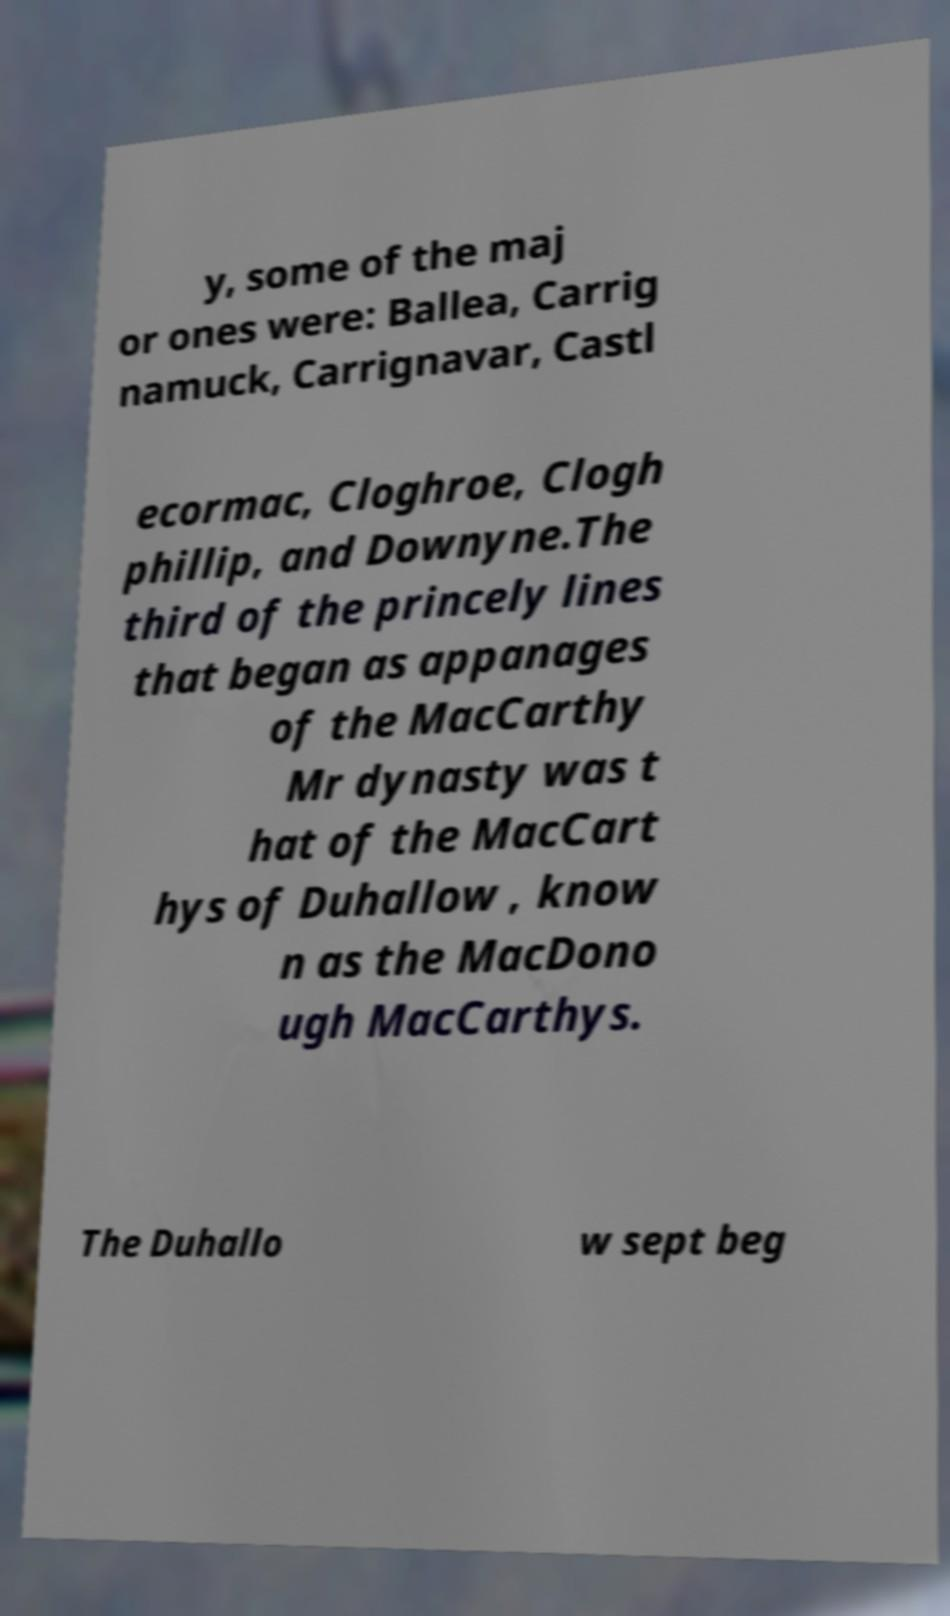Can you read and provide the text displayed in the image?This photo seems to have some interesting text. Can you extract and type it out for me? y, some of the maj or ones were: Ballea, Carrig namuck, Carrignavar, Castl ecormac, Cloghroe, Clogh phillip, and Downyne.The third of the princely lines that began as appanages of the MacCarthy Mr dynasty was t hat of the MacCart hys of Duhallow , know n as the MacDono ugh MacCarthys. The Duhallo w sept beg 